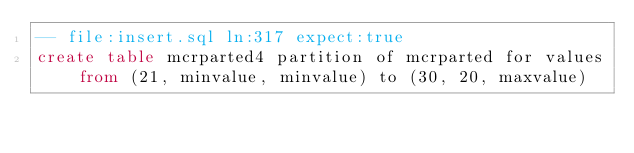<code> <loc_0><loc_0><loc_500><loc_500><_SQL_>-- file:insert.sql ln:317 expect:true
create table mcrparted4 partition of mcrparted for values from (21, minvalue, minvalue) to (30, 20, maxvalue)
</code> 